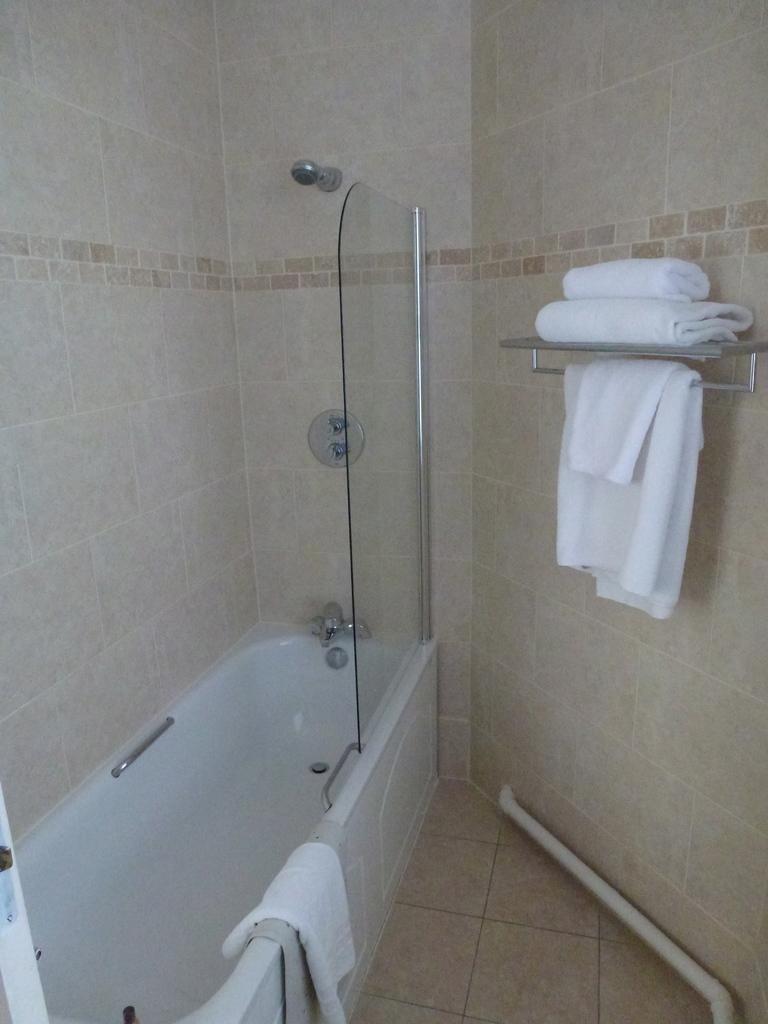How would you summarize this image in a sentence or two? This picture is clicked inside. On the left we can see white color bathtub and a towel and we can see the tap. On the right we can see a shelf on which we can see the towels are placed and we can see the towels are hanging on the metal rod. In the background we can see the wall. In the foreground we can see a pipe and the ground. 